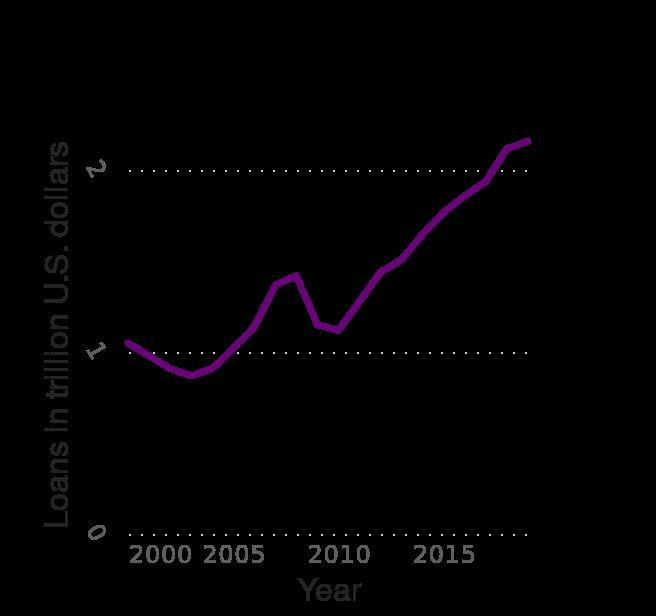<image>
What is the time period covered by the line plot? The line plot covers the time period from 2000 to 2019. What is the range of the y-axis on the line plot? The range of the y-axis on the line plot is 0 to 2 trillion U.S. dollars. 